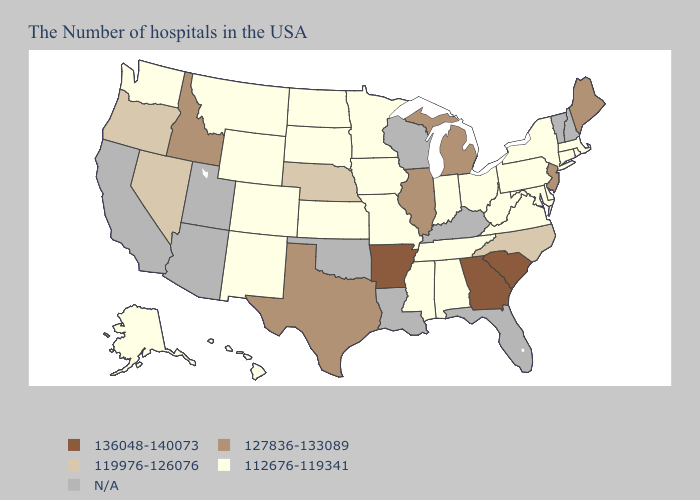Does Georgia have the highest value in the USA?
Concise answer only. Yes. Does Michigan have the lowest value in the USA?
Quick response, please. No. What is the highest value in the USA?
Be succinct. 136048-140073. Does Maryland have the lowest value in the South?
Concise answer only. Yes. Name the states that have a value in the range 136048-140073?
Keep it brief. South Carolina, Georgia, Arkansas. Which states have the lowest value in the USA?
Quick response, please. Massachusetts, Rhode Island, Connecticut, New York, Delaware, Maryland, Pennsylvania, Virginia, West Virginia, Ohio, Indiana, Alabama, Tennessee, Mississippi, Missouri, Minnesota, Iowa, Kansas, South Dakota, North Dakota, Wyoming, Colorado, New Mexico, Montana, Washington, Alaska, Hawaii. Which states have the lowest value in the MidWest?
Be succinct. Ohio, Indiana, Missouri, Minnesota, Iowa, Kansas, South Dakota, North Dakota. What is the value of North Carolina?
Answer briefly. 119976-126076. Name the states that have a value in the range 112676-119341?
Answer briefly. Massachusetts, Rhode Island, Connecticut, New York, Delaware, Maryland, Pennsylvania, Virginia, West Virginia, Ohio, Indiana, Alabama, Tennessee, Mississippi, Missouri, Minnesota, Iowa, Kansas, South Dakota, North Dakota, Wyoming, Colorado, New Mexico, Montana, Washington, Alaska, Hawaii. Name the states that have a value in the range 127836-133089?
Give a very brief answer. Maine, New Jersey, Michigan, Illinois, Texas, Idaho. Name the states that have a value in the range 112676-119341?
Concise answer only. Massachusetts, Rhode Island, Connecticut, New York, Delaware, Maryland, Pennsylvania, Virginia, West Virginia, Ohio, Indiana, Alabama, Tennessee, Mississippi, Missouri, Minnesota, Iowa, Kansas, South Dakota, North Dakota, Wyoming, Colorado, New Mexico, Montana, Washington, Alaska, Hawaii. Is the legend a continuous bar?
Be succinct. No. Name the states that have a value in the range N/A?
Answer briefly. New Hampshire, Vermont, Florida, Kentucky, Wisconsin, Louisiana, Oklahoma, Utah, Arizona, California. Name the states that have a value in the range 112676-119341?
Keep it brief. Massachusetts, Rhode Island, Connecticut, New York, Delaware, Maryland, Pennsylvania, Virginia, West Virginia, Ohio, Indiana, Alabama, Tennessee, Mississippi, Missouri, Minnesota, Iowa, Kansas, South Dakota, North Dakota, Wyoming, Colorado, New Mexico, Montana, Washington, Alaska, Hawaii. 